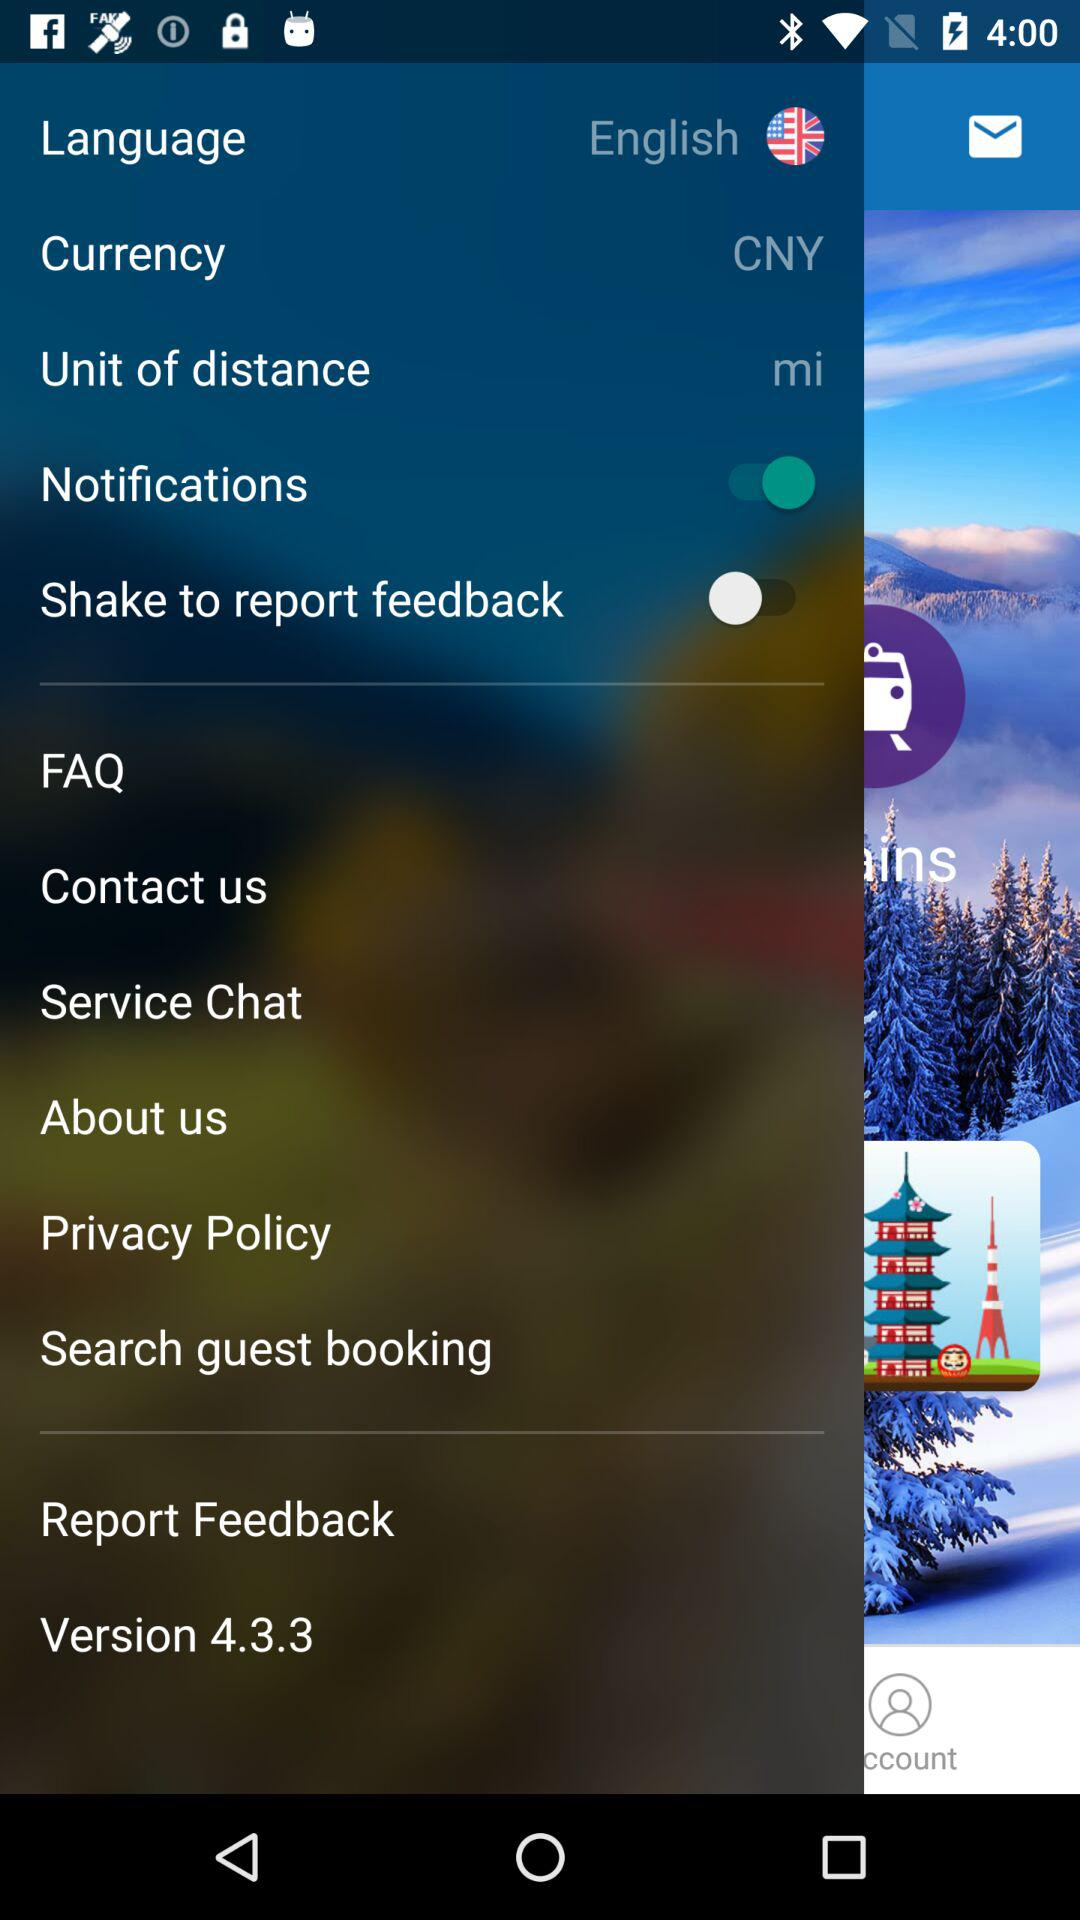What is the status of the "Notifications"? The status is "on". 